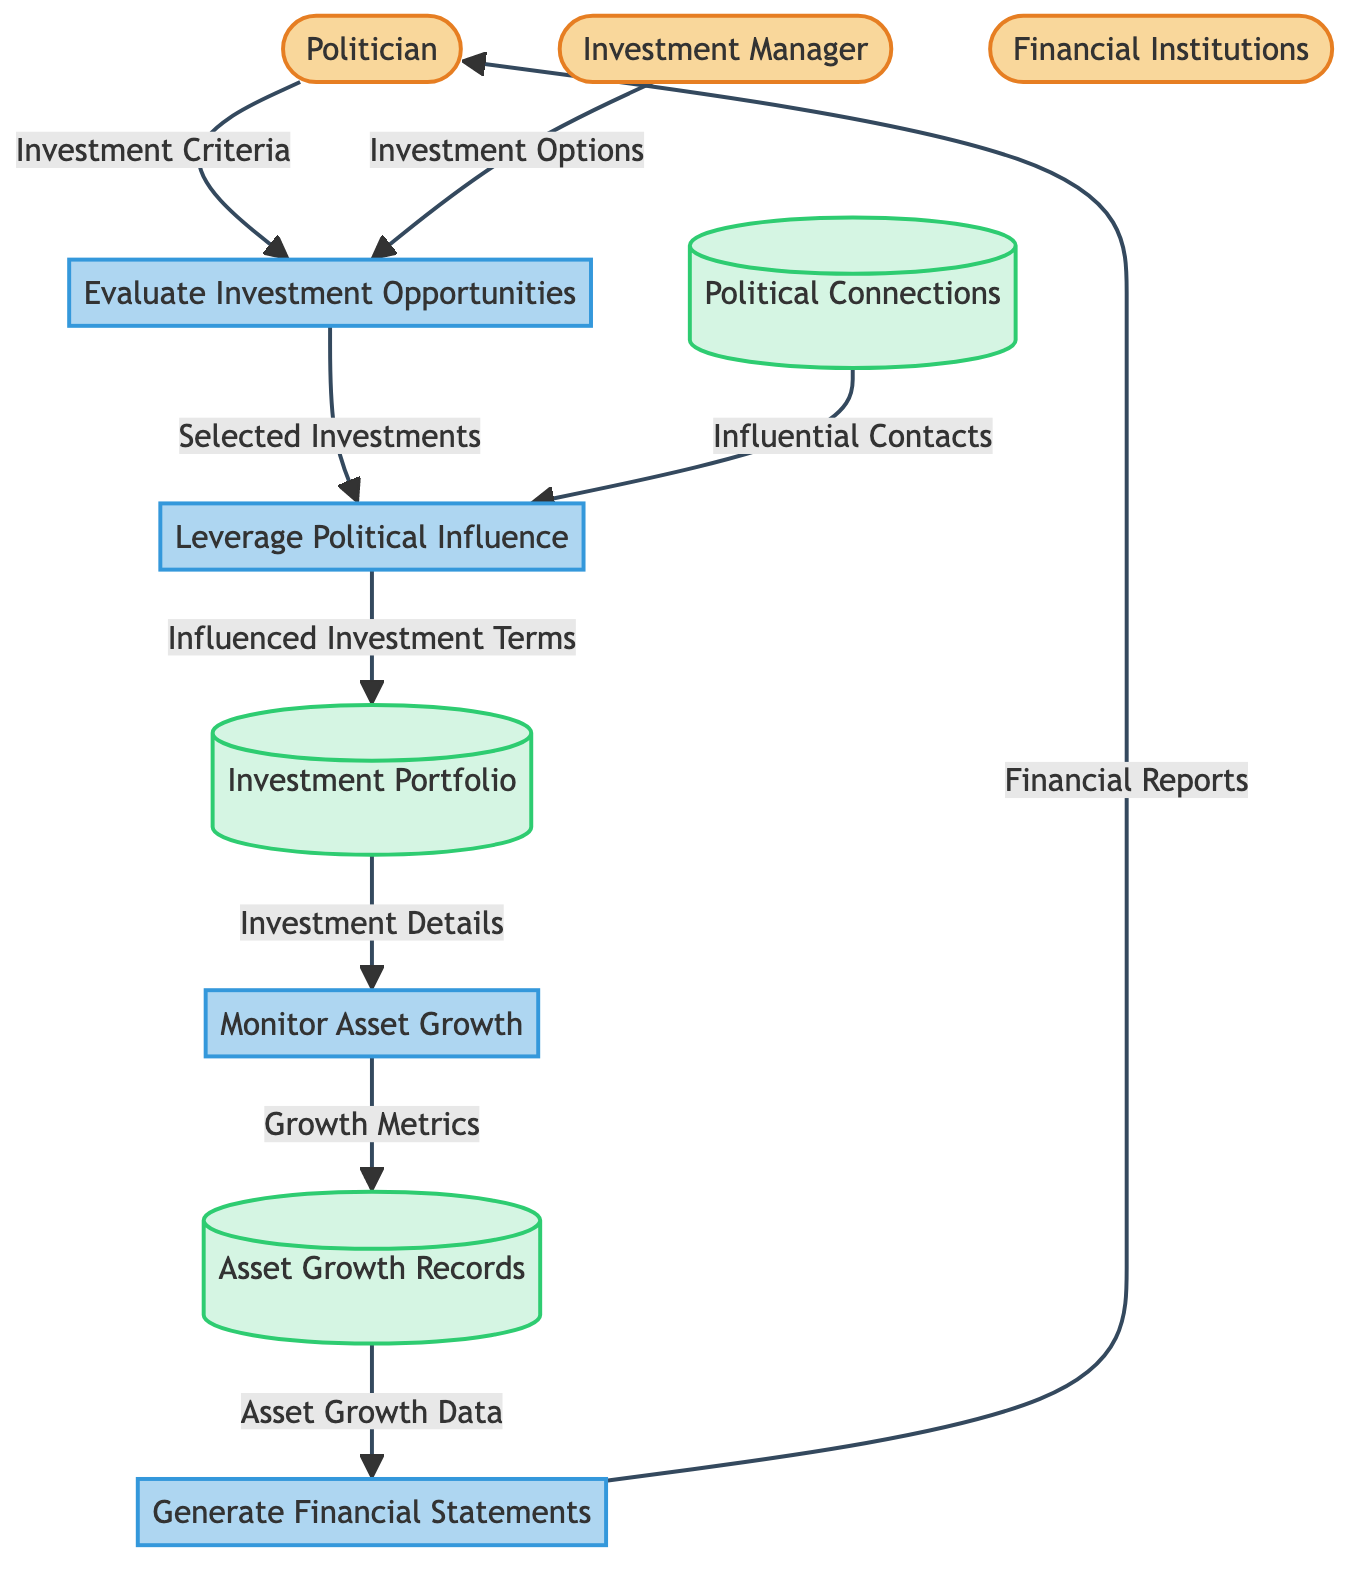What are the entities in this diagram? The diagram lists three external entities: Politician, Investment Manager, and Financial Institutions.
Answer: Politician, Investment Manager, Financial Institutions How many processes are represented in the diagram? There are four processes identified in the diagram: Evaluate Investment Opportunities, Leverage Political Influence, Monitor Asset Growth, and Generate Financial Statements.
Answer: Four What is the purpose of the “Leverage Political Influence” process? This process serves to utilize connections and power to ensure favorable investment terms and opportunities.
Answer: Utilize connections Which entity contributes “Investment Options” to the “Evaluate Investment Opportunities” process? The Investment Manager is the entity that provides Investment Options to this process.
Answer: Investment Manager What data stores are used in the diagram? The data stores represented are Investment Portfolio, Political Connections, and Asset Growth Records.
Answer: Investment Portfolio, Political Connections, Asset Growth Records What data flows from “Monitor Asset Growth” to “Asset Growth Records”? The data flowing from Monitor Asset Growth to Asset Growth Records is titled Growth Metrics.
Answer: Growth Metrics How do “Political Connections” influence the “Leverage Political Influence” process? Political Connections provide Influential Contacts that assist in leveraging political influence for investments.
Answer: Influential Contacts What is the final output delivered to the “Politician” in the diagram? The final output delivered to the Politician is Financial Reports that summarize asset growth and investment outcomes.
Answer: Financial Reports Which process follows “Evaluate Investment Opportunities” based on the diagram's flow? The process that follows Evaluate Investment Opportunities is Leverage Political Influence, which utilizes the selected investments.
Answer: Leverage Political Influence What type of data is stored in the “Asset Growth Records”? Asset Growth Records track data related to the growth and performance of investments, specifically Growth Metrics.
Answer: Growth Metrics 